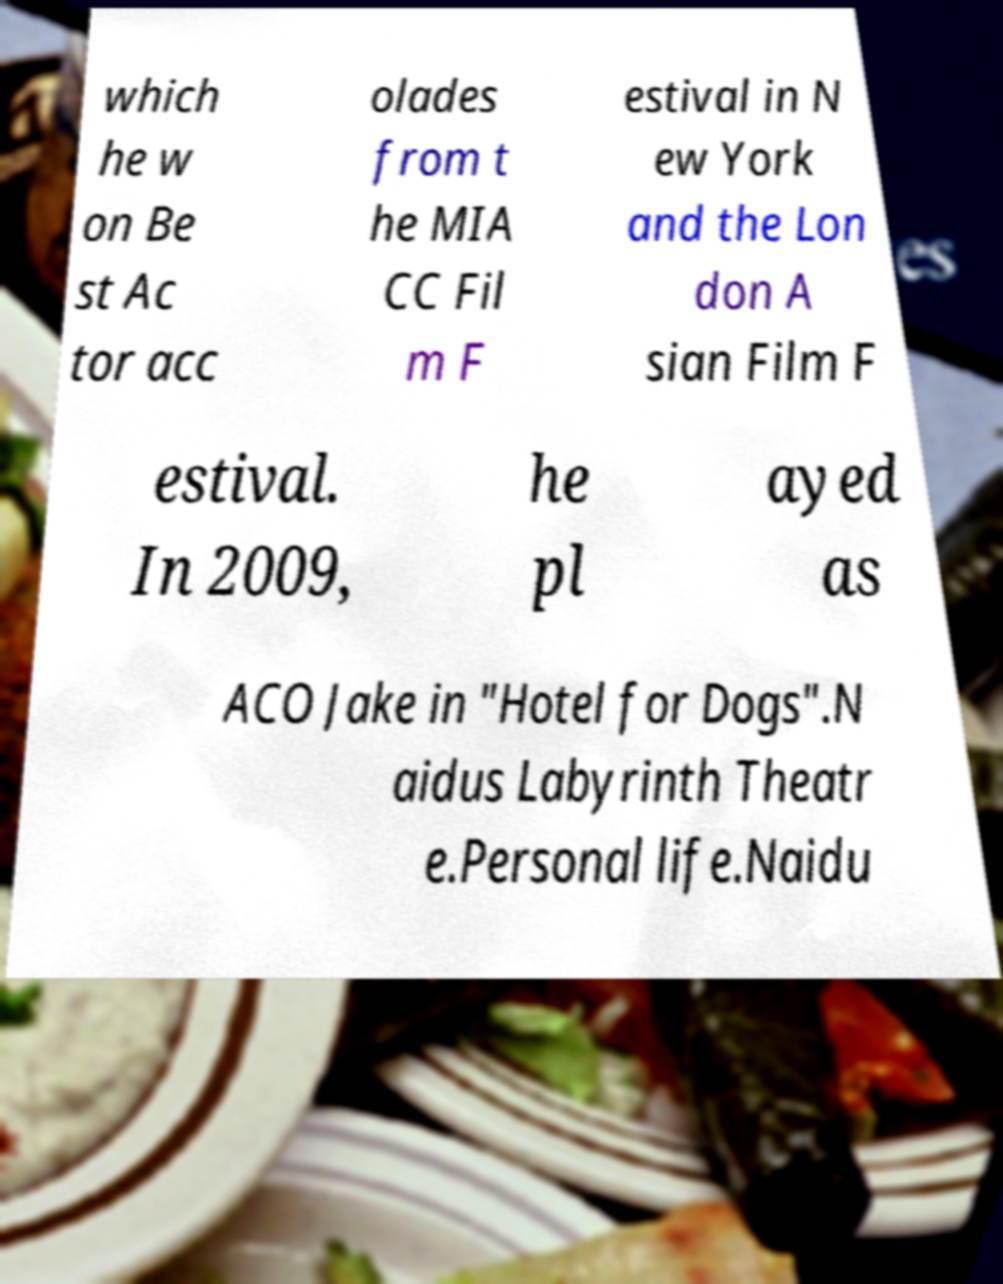Could you extract and type out the text from this image? which he w on Be st Ac tor acc olades from t he MIA CC Fil m F estival in N ew York and the Lon don A sian Film F estival. In 2009, he pl ayed as ACO Jake in "Hotel for Dogs".N aidus Labyrinth Theatr e.Personal life.Naidu 